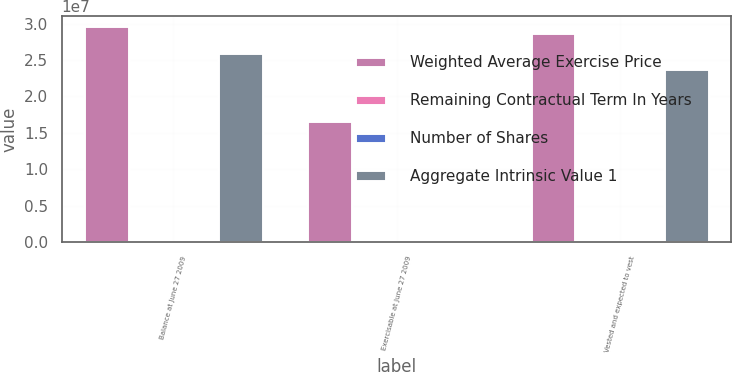<chart> <loc_0><loc_0><loc_500><loc_500><stacked_bar_chart><ecel><fcel>Balance at June 27 2009<fcel>Exercisable at June 27 2009<fcel>Vested and expected to vest<nl><fcel>Weighted Average Exercise Price<fcel>2.95999e+07<fcel>1.66179e+07<fcel>2.86595e+07<nl><fcel>Remaining Contractual Term In Years<fcel>28.83<fcel>34.79<fcel>29.19<nl><fcel>Number of Shares<fcel>4.6<fcel>3.3<fcel>4.5<nl><fcel>Aggregate Intrinsic Value 1<fcel>2.6022e+07<fcel>11612<fcel>2.37461e+07<nl></chart> 